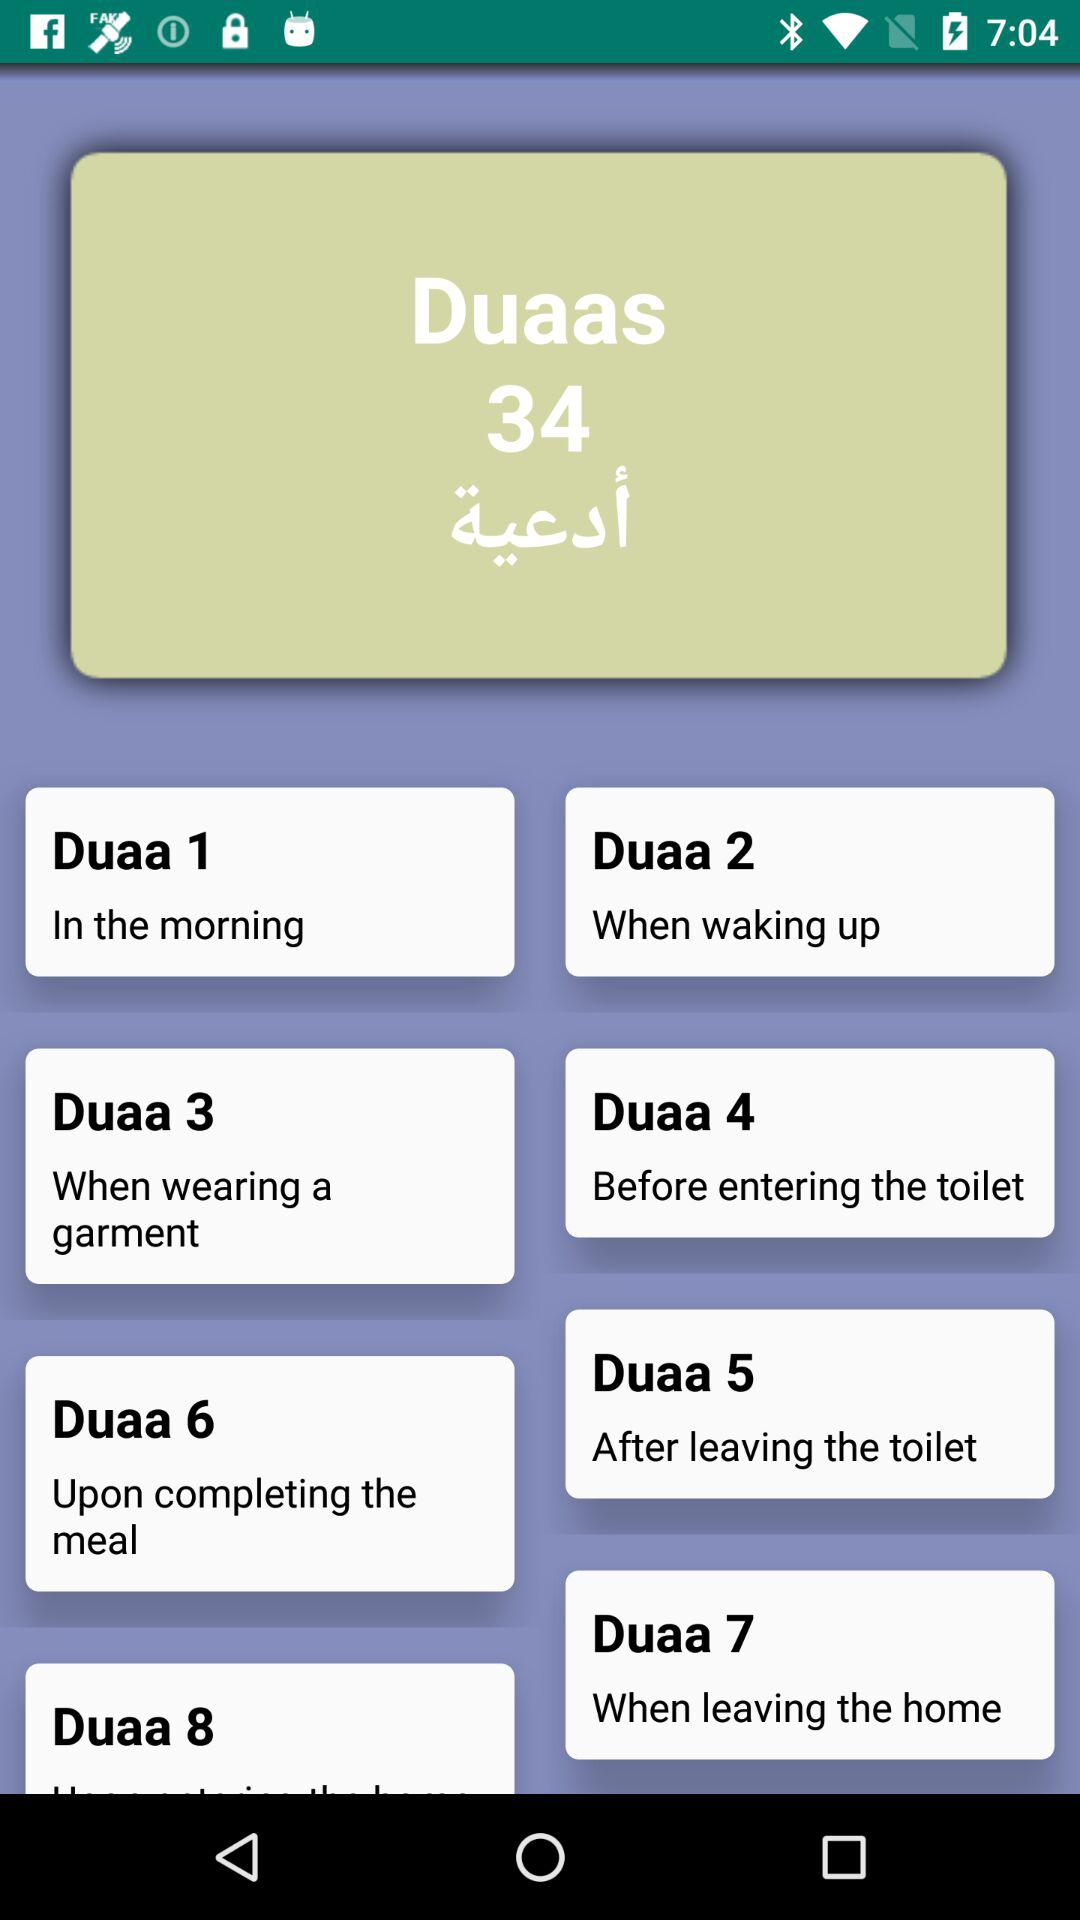How many duaas are there in total?
Answer the question using a single word or phrase. 8 